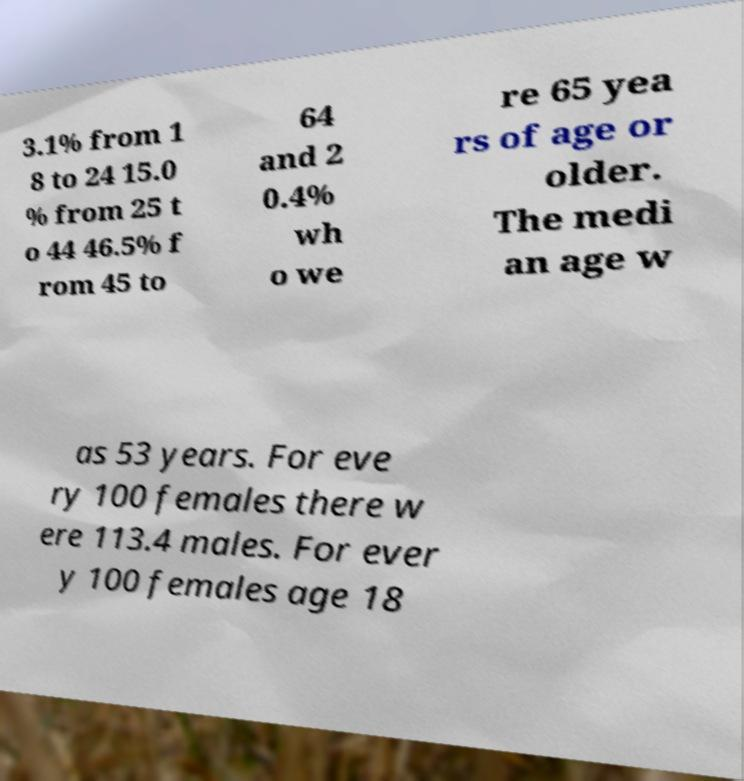I need the written content from this picture converted into text. Can you do that? 3.1% from 1 8 to 24 15.0 % from 25 t o 44 46.5% f rom 45 to 64 and 2 0.4% wh o we re 65 yea rs of age or older. The medi an age w as 53 years. For eve ry 100 females there w ere 113.4 males. For ever y 100 females age 18 